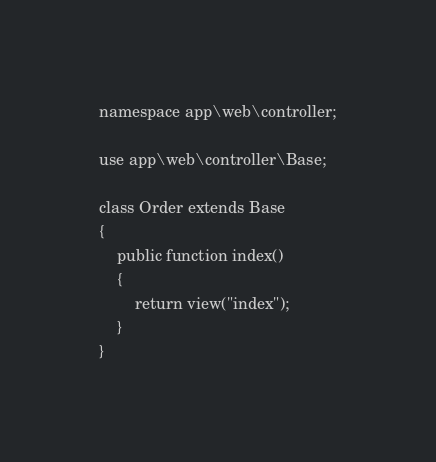Convert code to text. <code><loc_0><loc_0><loc_500><loc_500><_PHP_>namespace app\web\controller;

use app\web\controller\Base;

class Order extends Base
{
    public function index()
    {
        return view("index");
    }
}
</code> 